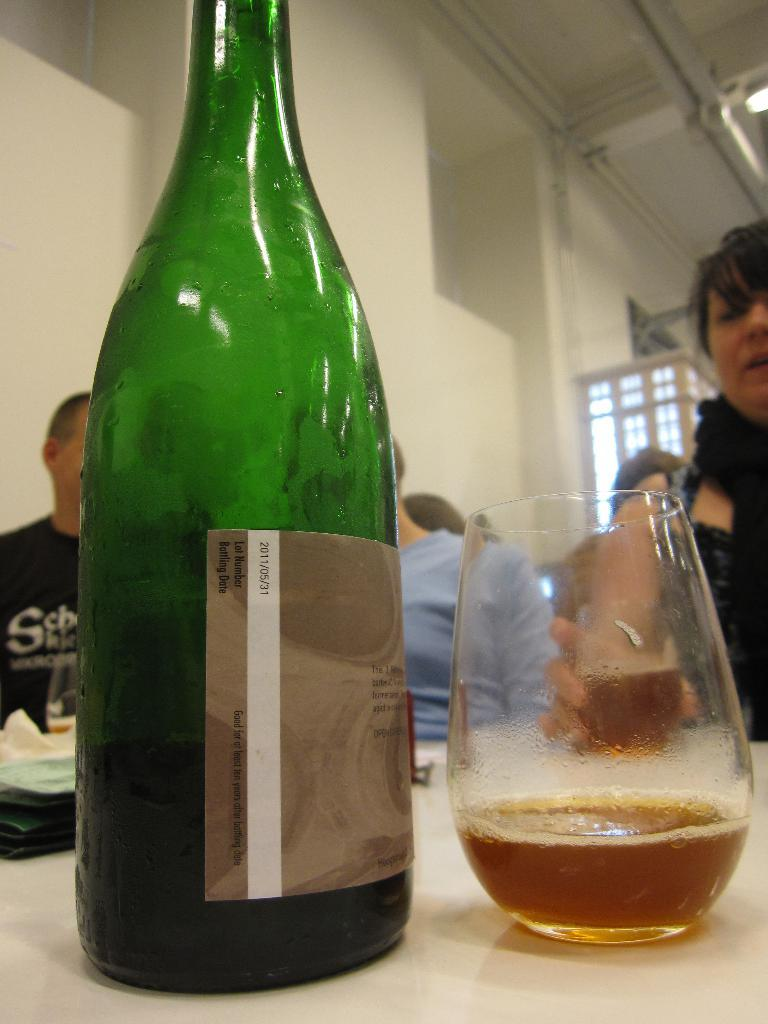What is one object visible in the image? There is a bottle in the image. What is another object visible in the image? There is a glass in the image. Can you describe the setting in the background of the image? People are sitting at a table in the background of the image. What type of hand can be seen holding the bottle in the image? There is no hand visible holding the bottle in the image. Are there any dinosaurs present in the image? No, there are no dinosaurs present in the image. 